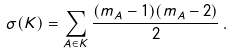Convert formula to latex. <formula><loc_0><loc_0><loc_500><loc_500>\sigma ( K ) = \sum _ { A \in K } \frac { ( m _ { A } - 1 ) ( m _ { A } - 2 ) } { 2 } \, .</formula> 